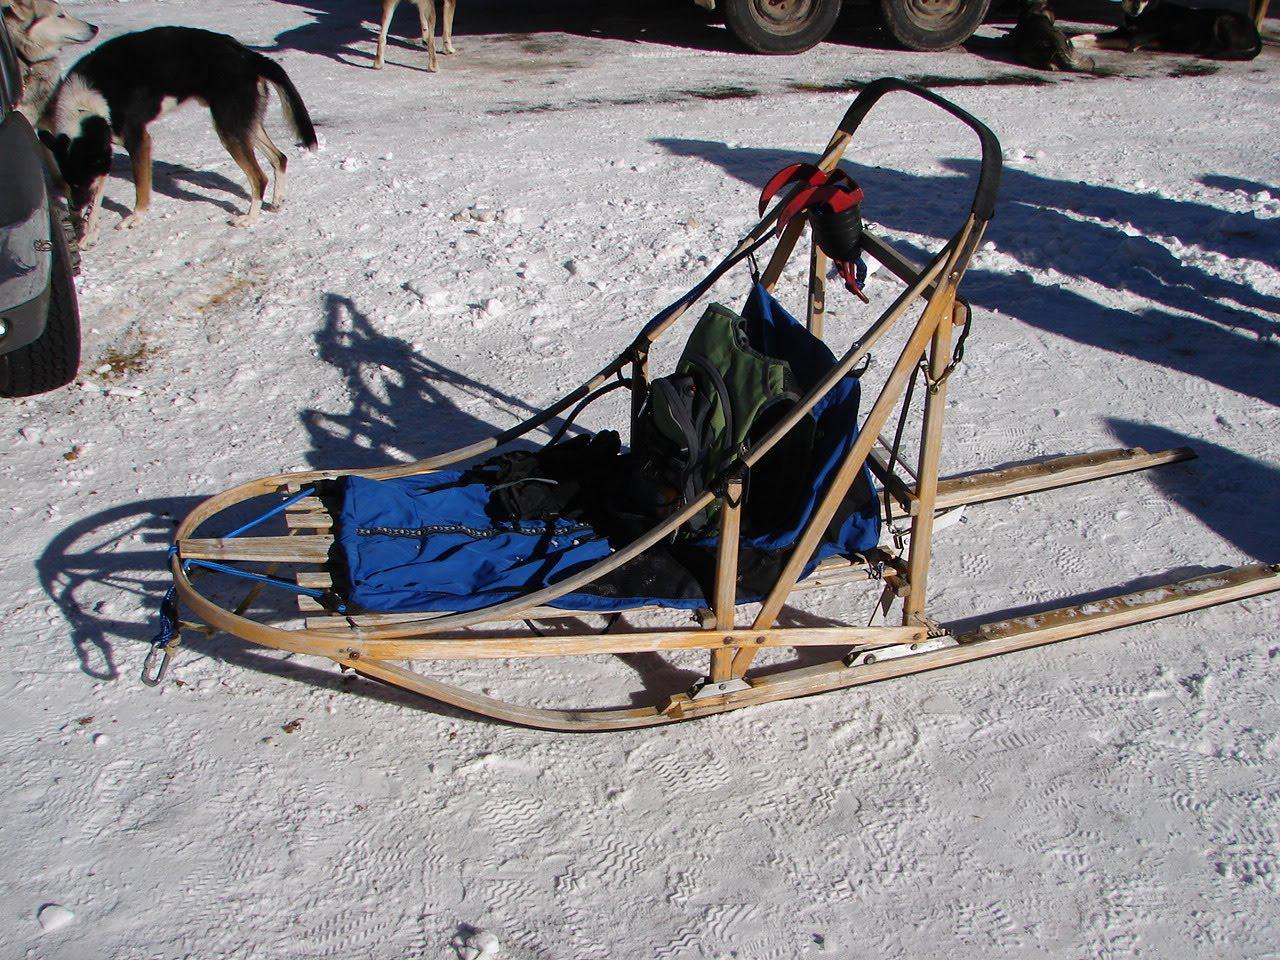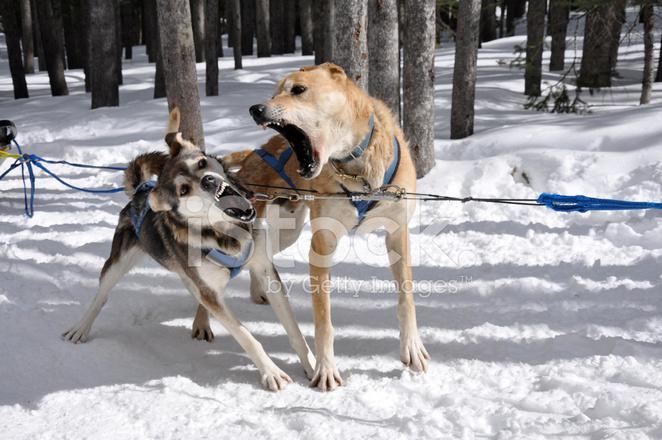The first image is the image on the left, the second image is the image on the right. Assess this claim about the two images: "One image shows an empty, unhitched, leftward-facing sled in the foreground, and the other image includes sled dogs in the foreground.". Correct or not? Answer yes or no. Yes. The first image is the image on the left, the second image is the image on the right. Given the left and right images, does the statement "One image shows dogs that are part of a sled racing team and the other shows only the sled." hold true? Answer yes or no. Yes. 